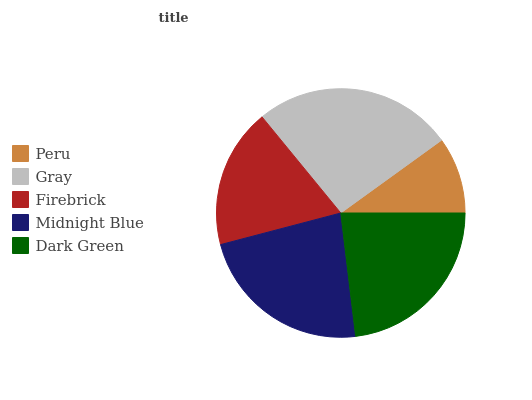Is Peru the minimum?
Answer yes or no. Yes. Is Gray the maximum?
Answer yes or no. Yes. Is Firebrick the minimum?
Answer yes or no. No. Is Firebrick the maximum?
Answer yes or no. No. Is Gray greater than Firebrick?
Answer yes or no. Yes. Is Firebrick less than Gray?
Answer yes or no. Yes. Is Firebrick greater than Gray?
Answer yes or no. No. Is Gray less than Firebrick?
Answer yes or no. No. Is Midnight Blue the high median?
Answer yes or no. Yes. Is Midnight Blue the low median?
Answer yes or no. Yes. Is Gray the high median?
Answer yes or no. No. Is Peru the low median?
Answer yes or no. No. 